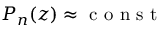Convert formula to latex. <formula><loc_0><loc_0><loc_500><loc_500>P _ { n } ( z ) \approx c o n s t</formula> 